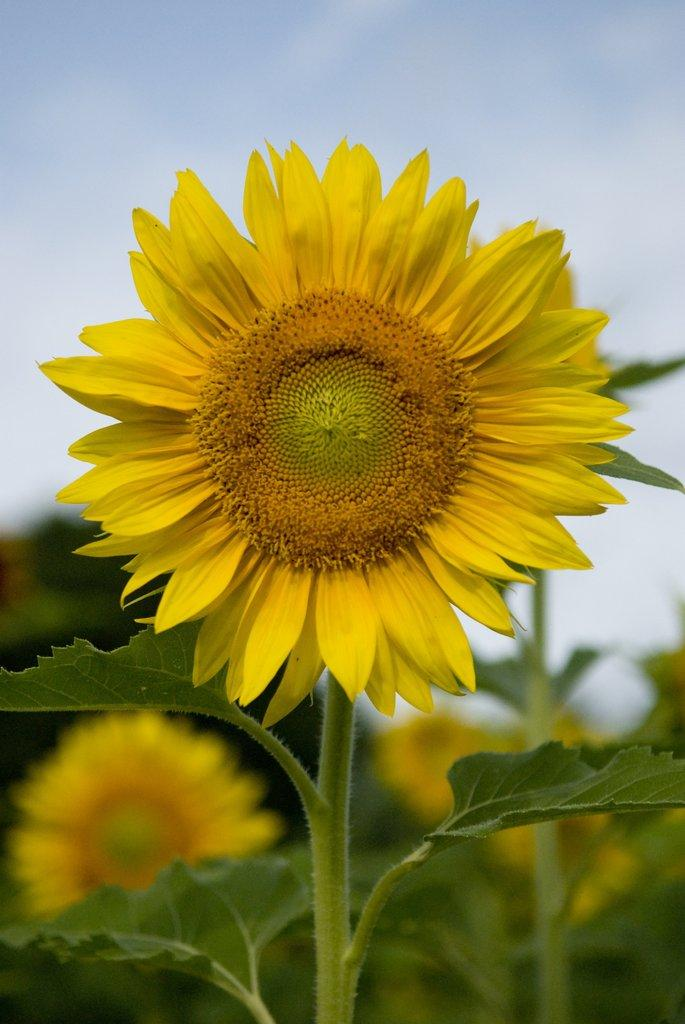What type of plant is in the image? There is a sunflower in the image. What are the main parts of the sunflower? The sunflower has stems and leaves. How would you describe the background of the image? The background of the image is blurred. What other types of plants can be seen in the image? Flowers are visible in the image. What else is visible in the background of the image? The sky is visible in the image. What direction is the sunflower facing in the image? The direction the sunflower is facing cannot be determined from the image. What is the sister of the sunflower doing in the image? There is no mention of a sister plant or any other plants in the image. 